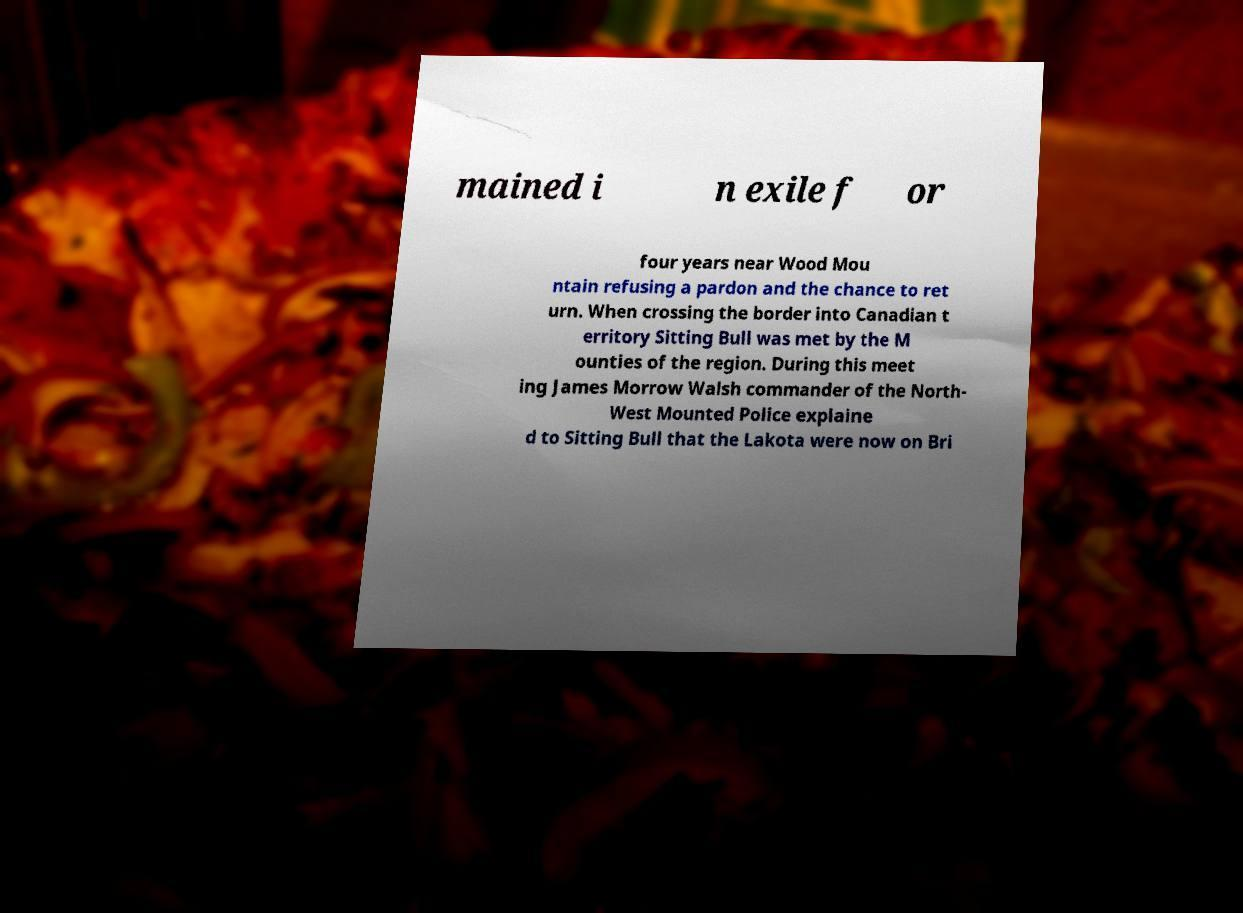Can you read and provide the text displayed in the image?This photo seems to have some interesting text. Can you extract and type it out for me? mained i n exile f or four years near Wood Mou ntain refusing a pardon and the chance to ret urn. When crossing the border into Canadian t erritory Sitting Bull was met by the M ounties of the region. During this meet ing James Morrow Walsh commander of the North- West Mounted Police explaine d to Sitting Bull that the Lakota were now on Bri 